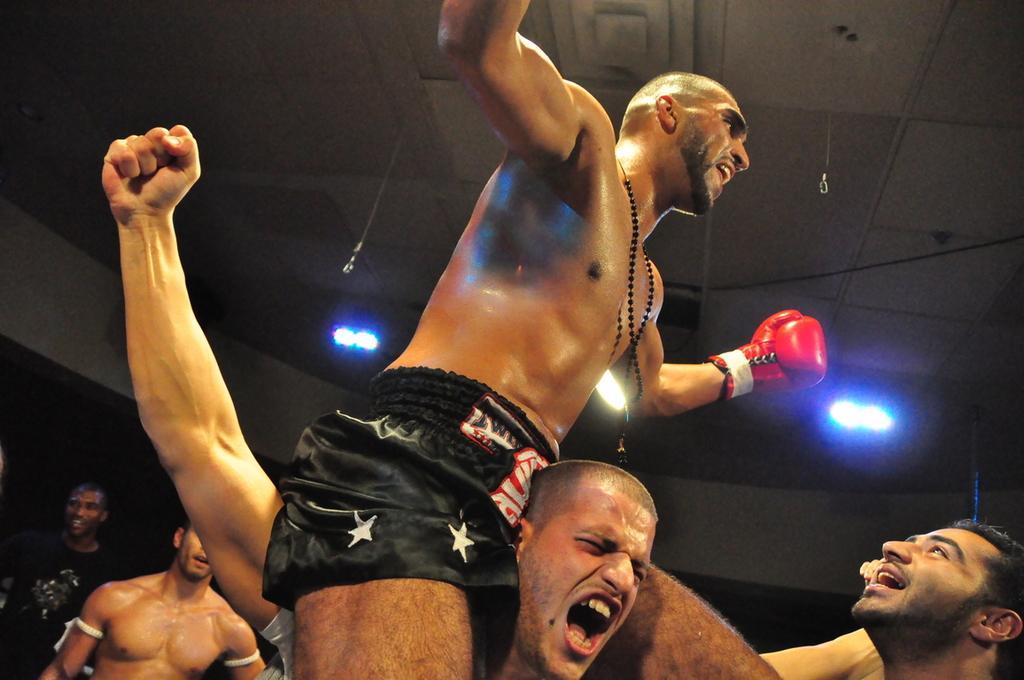Could you give a brief overview of what you see in this image? In this image we can see the people standing. At the top we can see the ceiling with lights. 